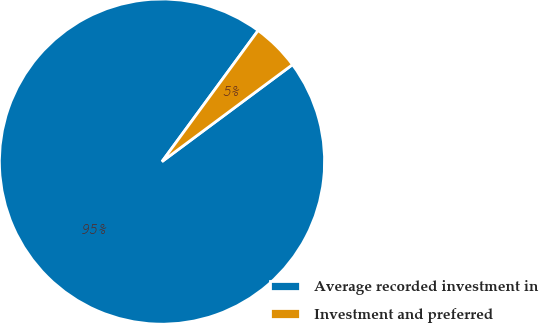Convert chart to OTSL. <chart><loc_0><loc_0><loc_500><loc_500><pie_chart><fcel>Average recorded investment in<fcel>Investment and preferred<nl><fcel>95.24%<fcel>4.76%<nl></chart> 